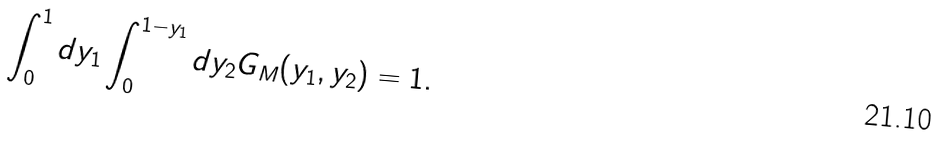Convert formula to latex. <formula><loc_0><loc_0><loc_500><loc_500>\int ^ { 1 } _ { 0 } d y _ { 1 } \int ^ { 1 - y _ { 1 } } _ { 0 } d y _ { 2 } G _ { M } ( y _ { 1 } , y _ { 2 } ) = 1 .</formula> 